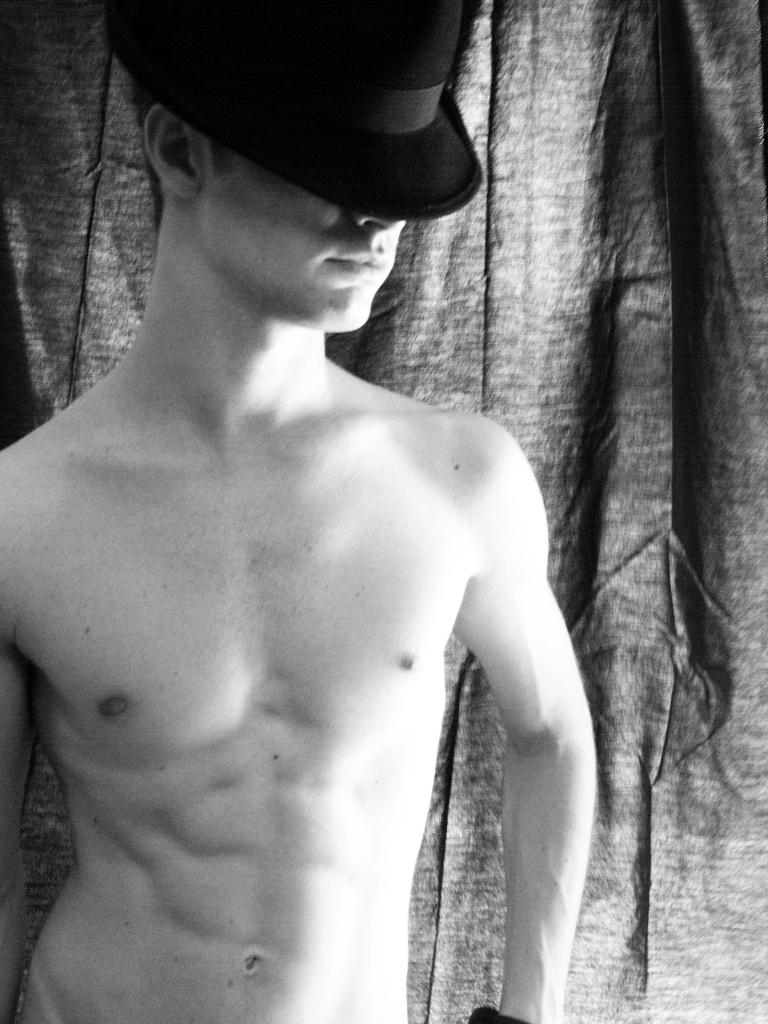What is the color scheme of the image? The image is black and white. Can you describe the person in the image? There is a person in the image, and they are wearing a hat. What else can be seen in the image besides the person? There is a curtain visible in the image. How many potatoes are being crushed by the cart in the image? There are no potatoes or carts present in the image. 